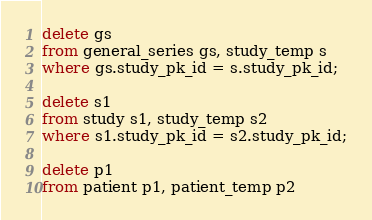Convert code to text. <code><loc_0><loc_0><loc_500><loc_500><_SQL_>delete gs
from general_series gs, study_temp s
where gs.study_pk_id = s.study_pk_id; 

delete s1
from study s1, study_temp s2
where s1.study_pk_id = s2.study_pk_id;

delete p1
from patient p1, patient_temp p2</code> 